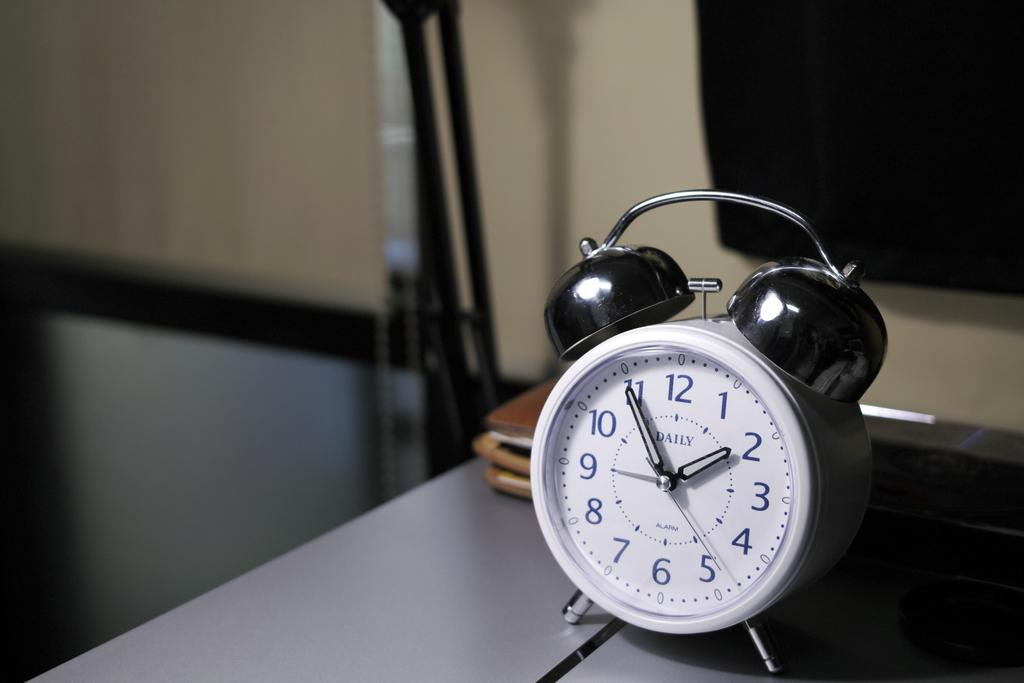<image>
Share a concise interpretation of the image provided. An alarm clock says "daily" on the face and sits on a gray table. 